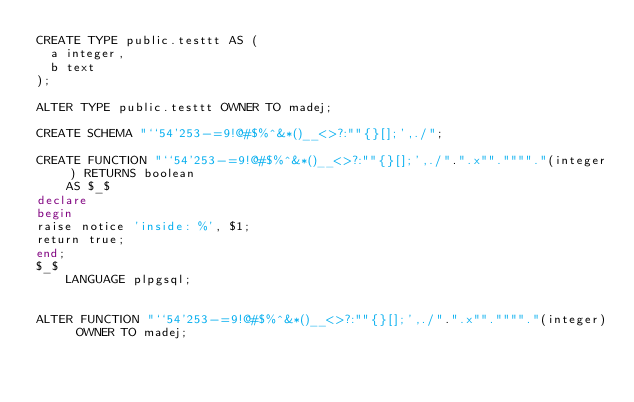Convert code to text. <code><loc_0><loc_0><loc_500><loc_500><_SQL_>CREATE TYPE public.testtt AS (
	a integer,
	b text
);

ALTER TYPE public.testtt OWNER TO madej;

CREATE SCHEMA "``54'253-=9!@#$%^&*()__<>?:""{}[];',./";

CREATE FUNCTION "``54'253-=9!@#$%^&*()__<>?:""{}[];',./".".x"".""""."(integer) RETURNS boolean
    AS $_$
declare
begin
raise notice 'inside: %', $1;
return true;
end;
$_$
    LANGUAGE plpgsql;


ALTER FUNCTION "``54'253-=9!@#$%^&*()__<>?:""{}[];',./".".x"".""""."(integer) OWNER TO madej;</code> 